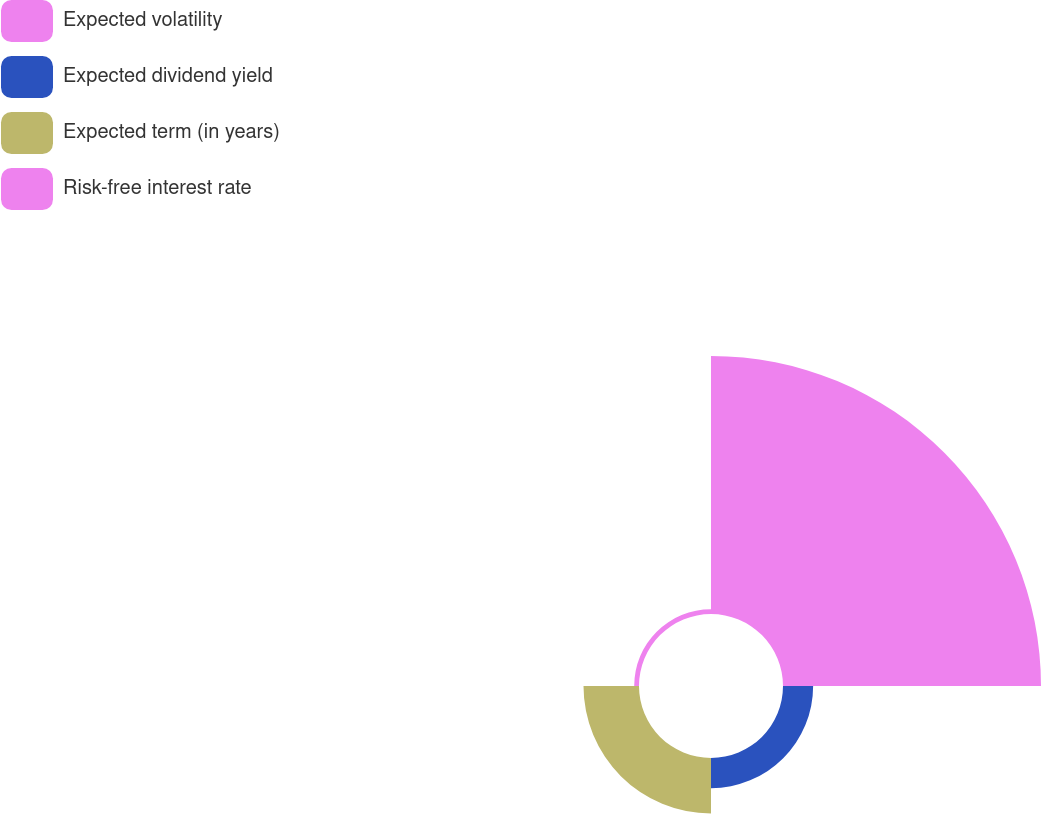Convert chart to OTSL. <chart><loc_0><loc_0><loc_500><loc_500><pie_chart><fcel>Expected volatility<fcel>Expected dividend yield<fcel>Expected term (in years)<fcel>Risk-free interest rate<nl><fcel>74.05%<fcel>8.65%<fcel>15.93%<fcel>1.38%<nl></chart> 